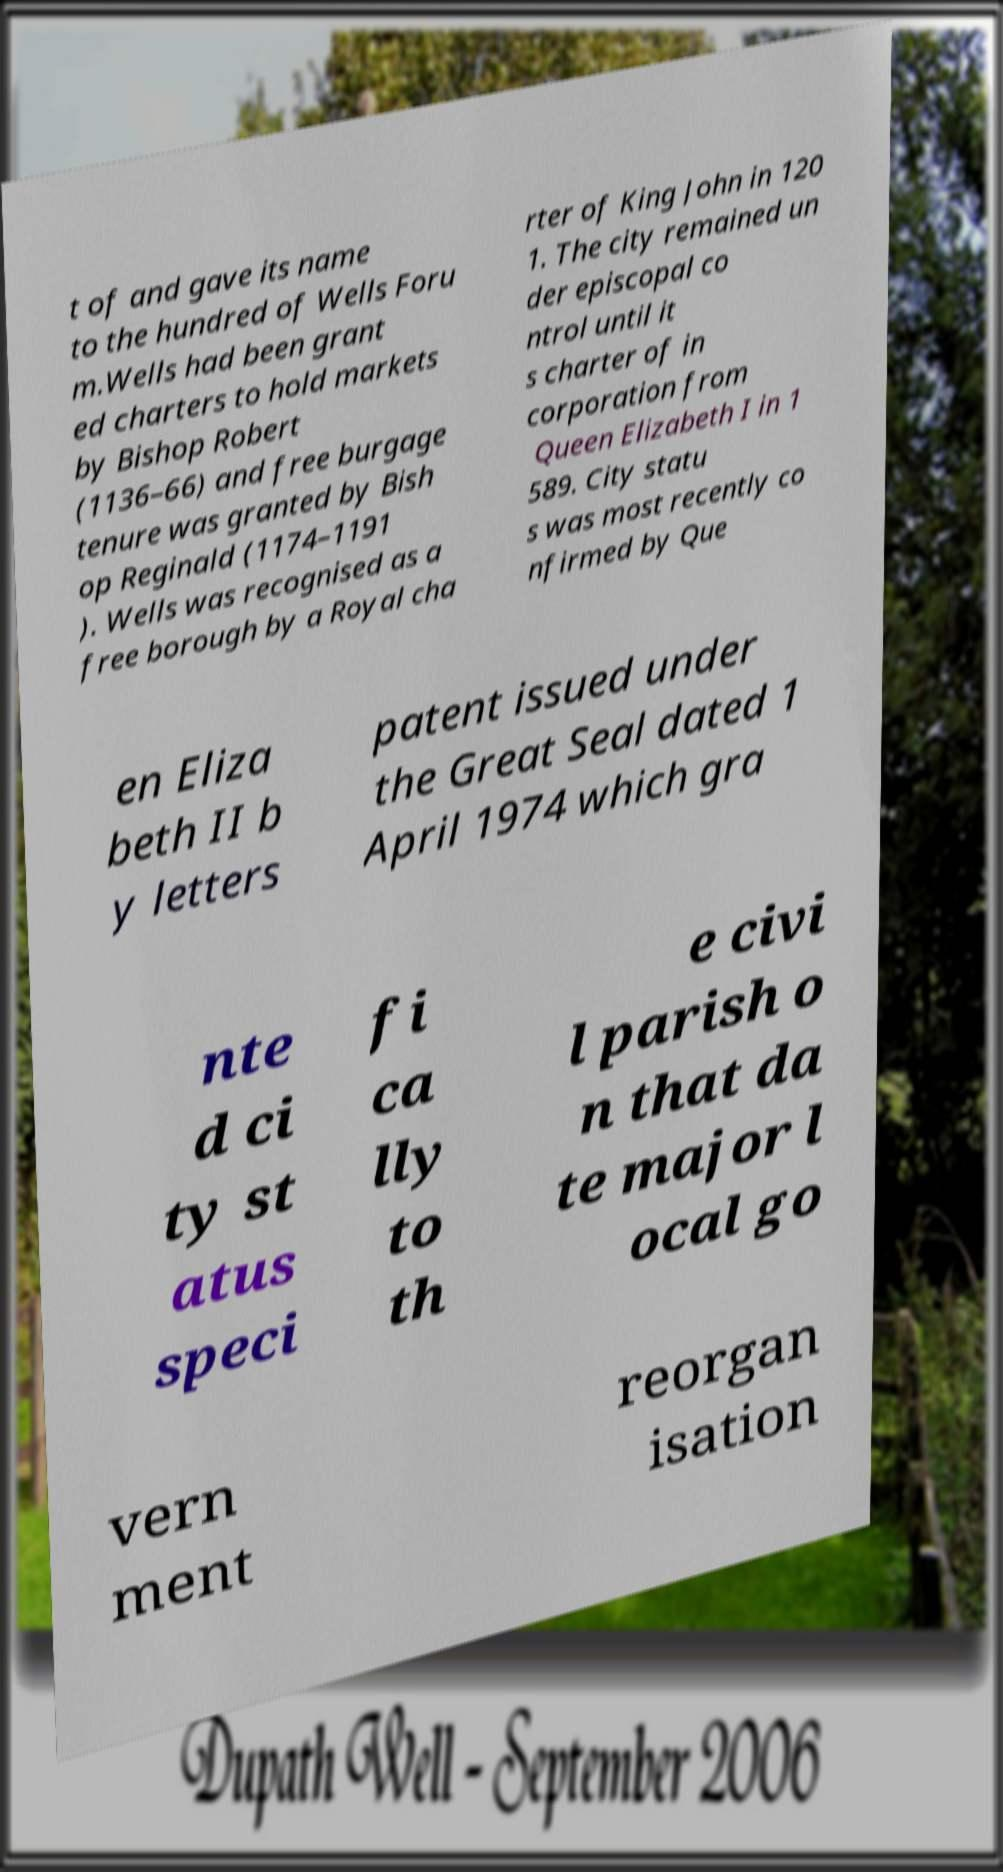Please identify and transcribe the text found in this image. t of and gave its name to the hundred of Wells Foru m.Wells had been grant ed charters to hold markets by Bishop Robert (1136–66) and free burgage tenure was granted by Bish op Reginald (1174–1191 ). Wells was recognised as a free borough by a Royal cha rter of King John in 120 1. The city remained un der episcopal co ntrol until it s charter of in corporation from Queen Elizabeth I in 1 589. City statu s was most recently co nfirmed by Que en Eliza beth II b y letters patent issued under the Great Seal dated 1 April 1974 which gra nte d ci ty st atus speci fi ca lly to th e civi l parish o n that da te major l ocal go vern ment reorgan isation 